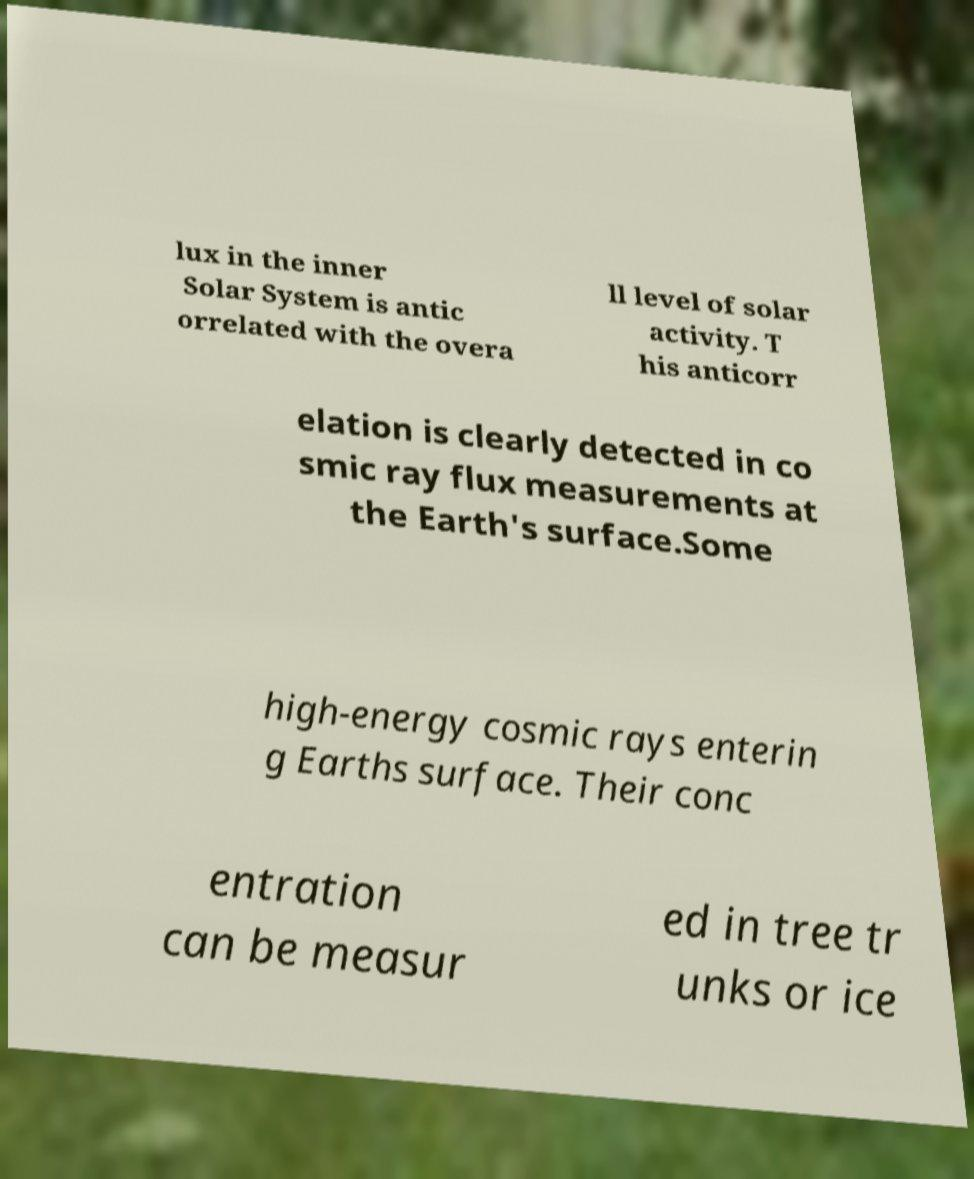Can you accurately transcribe the text from the provided image for me? lux in the inner Solar System is antic orrelated with the overa ll level of solar activity. T his anticorr elation is clearly detected in co smic ray flux measurements at the Earth's surface.Some high-energy cosmic rays enterin g Earths surface. Their conc entration can be measur ed in tree tr unks or ice 